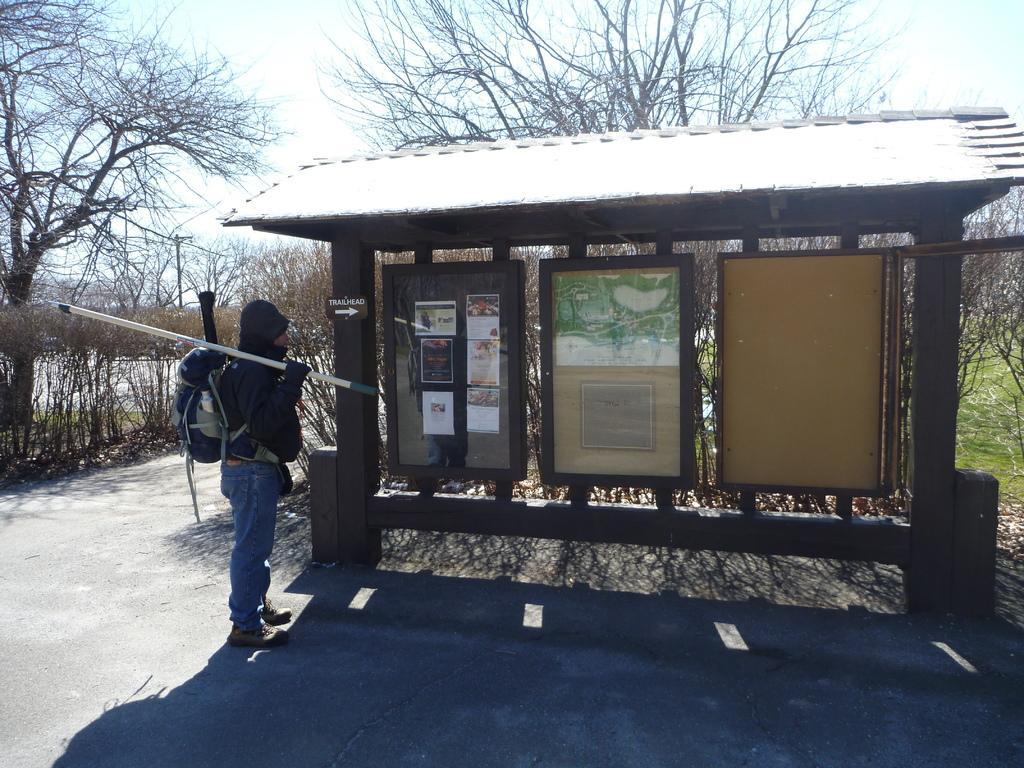Please provide a concise description of this image. In this image I can see there is a person standing on the road and holding a stick and carrying bag. And there is a shed with boards. And there are posters attached to the board. And there is a grass, Trees, and a pole. And at the top there is a sky. 